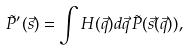<formula> <loc_0><loc_0><loc_500><loc_500>\tilde { P } ^ { \prime } ( \vec { s } ) = \int H ( \vec { q } ) d \vec { q } \, \tilde { P } ( \vec { s } ( \vec { q } ) ) ,</formula> 